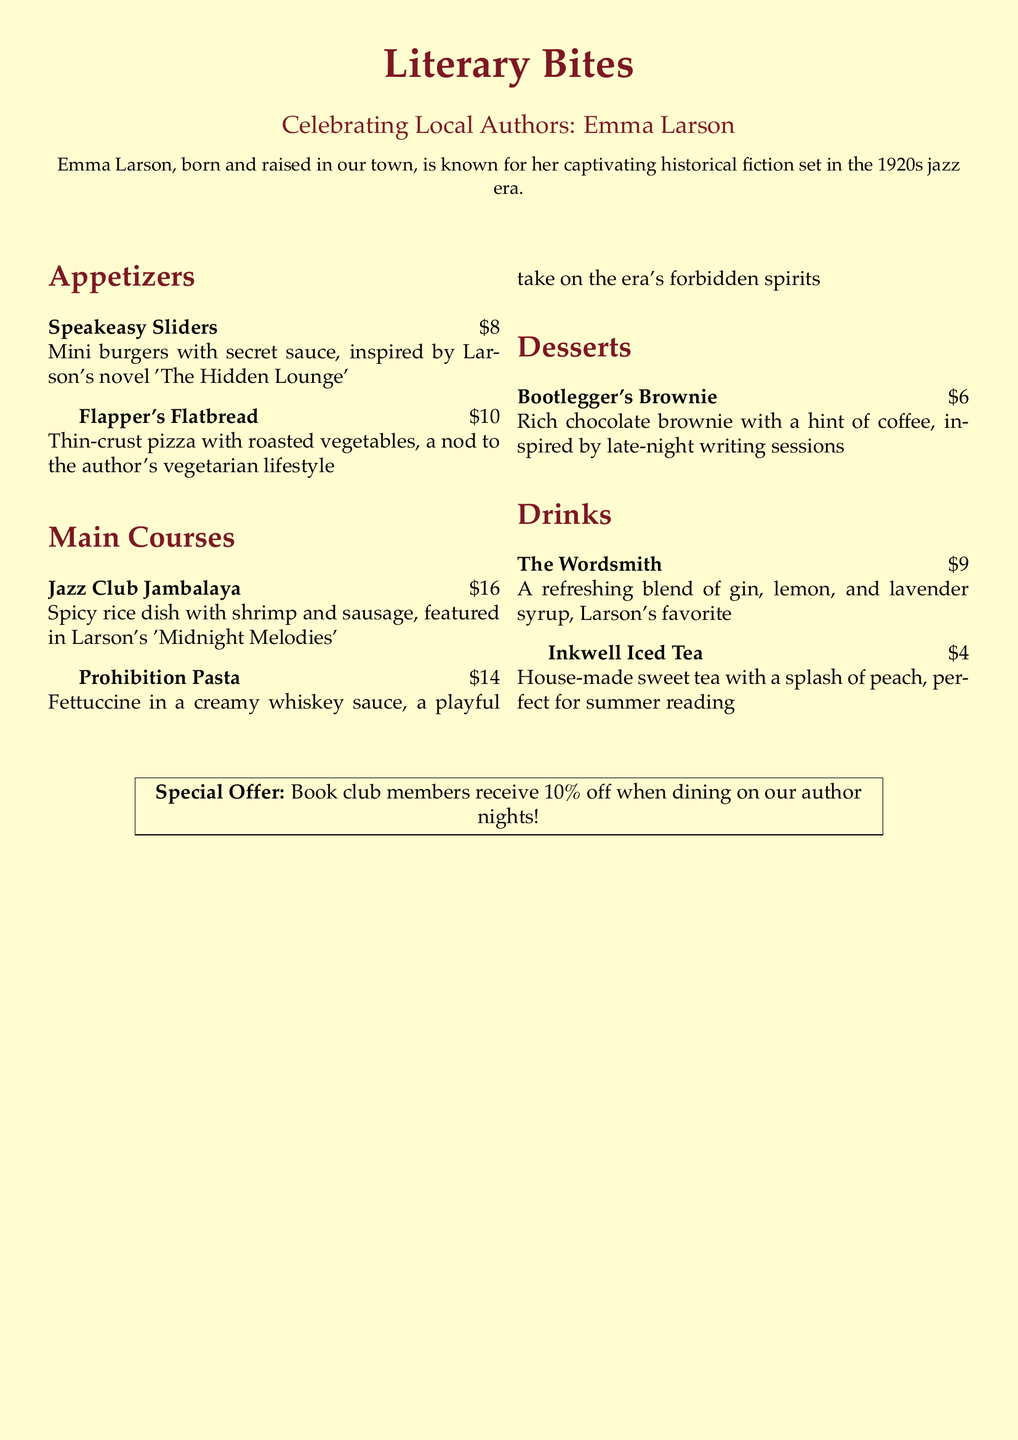What is the name of the author being celebrated this month? The document states that the themed menu is celebrating local author Emma Larson.
Answer: Emma Larson What is the price of the Bootlegger's Brownie? The document lists the price of the Bootlegger's Brownie as $6.
Answer: $6 Which novel inspired the Speakeasy Sliders? The Speakeasy Sliders are inspired by Larson's novel 'The Hidden Lounge'.
Answer: 'The Hidden Lounge' What type of sauce is featured in the Prohibition Pasta? The Prohibition Pasta features a creamy whiskey sauce.
Answer: creamy whiskey sauce How much do book club members receive as a discount? The special offer for book club members is a 10% discount on dining.
Answer: 10% What is the main ingredient in The Wordsmith drink? The Wordsmith drink includes a refreshing blend of gin, lemon, and lavender syrup.
Answer: gin How much does the Jazz Club Jambalaya cost? The document states that the Jazz Club Jambalaya is priced at $16.
Answer: $16 What is a notable feature of the Flapper's Flatbread? The Flapper's Flatbread features roasted vegetables and reflects the author's vegetarian lifestyle.
Answer: roasted vegetables What is the house-made tea served with? The Inkwell Iced Tea is served with a splash of peach.
Answer: splash of peach 